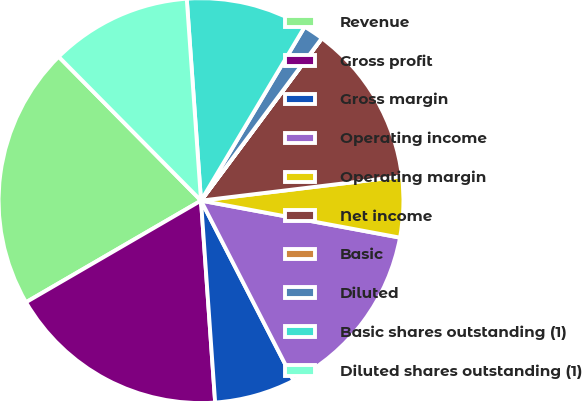Convert chart. <chart><loc_0><loc_0><loc_500><loc_500><pie_chart><fcel>Revenue<fcel>Gross profit<fcel>Gross margin<fcel>Operating income<fcel>Operating margin<fcel>Net income<fcel>Basic<fcel>Diluted<fcel>Basic shares outstanding (1)<fcel>Diluted shares outstanding (1)<nl><fcel>20.96%<fcel>17.74%<fcel>6.45%<fcel>14.51%<fcel>4.84%<fcel>12.9%<fcel>0.01%<fcel>1.62%<fcel>9.68%<fcel>11.29%<nl></chart> 